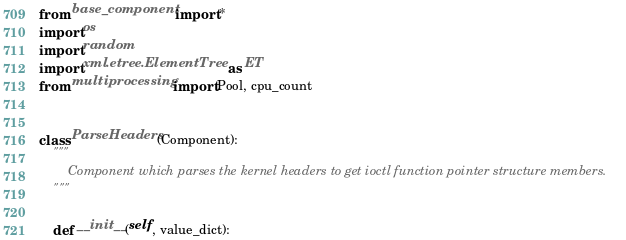Convert code to text. <code><loc_0><loc_0><loc_500><loc_500><_Python_>from base_component import *
import os
import random
import xml.etree.ElementTree as ET
from multiprocessing import Pool, cpu_count


class ParseHeaders(Component):
    """
        Component which parses the kernel headers to get ioctl function pointer structure members.
    """

    def __init__(self, value_dict):</code> 